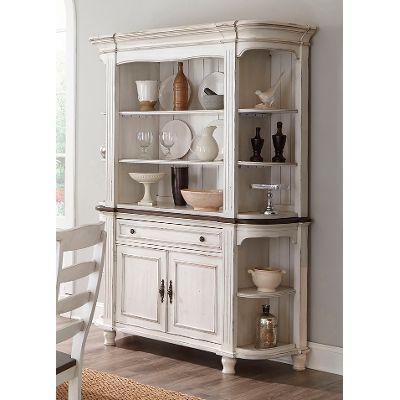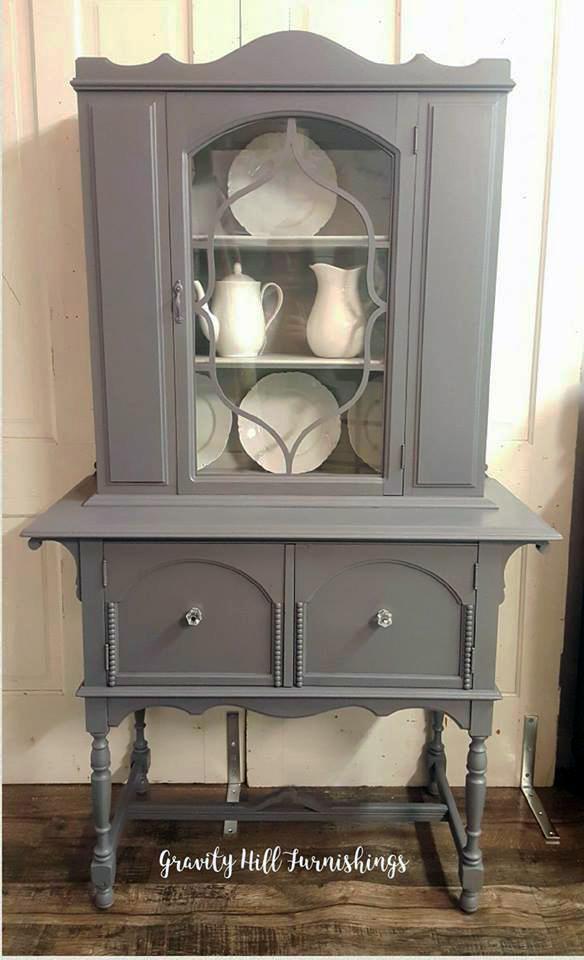The first image is the image on the left, the second image is the image on the right. Examine the images to the left and right. Is the description "The right image contains a chair." accurate? Answer yes or no. No. The first image is the image on the left, the second image is the image on the right. Analyze the images presented: Is the assertion "There are objects in the white cabinet in the image on the left." valid? Answer yes or no. Yes. 